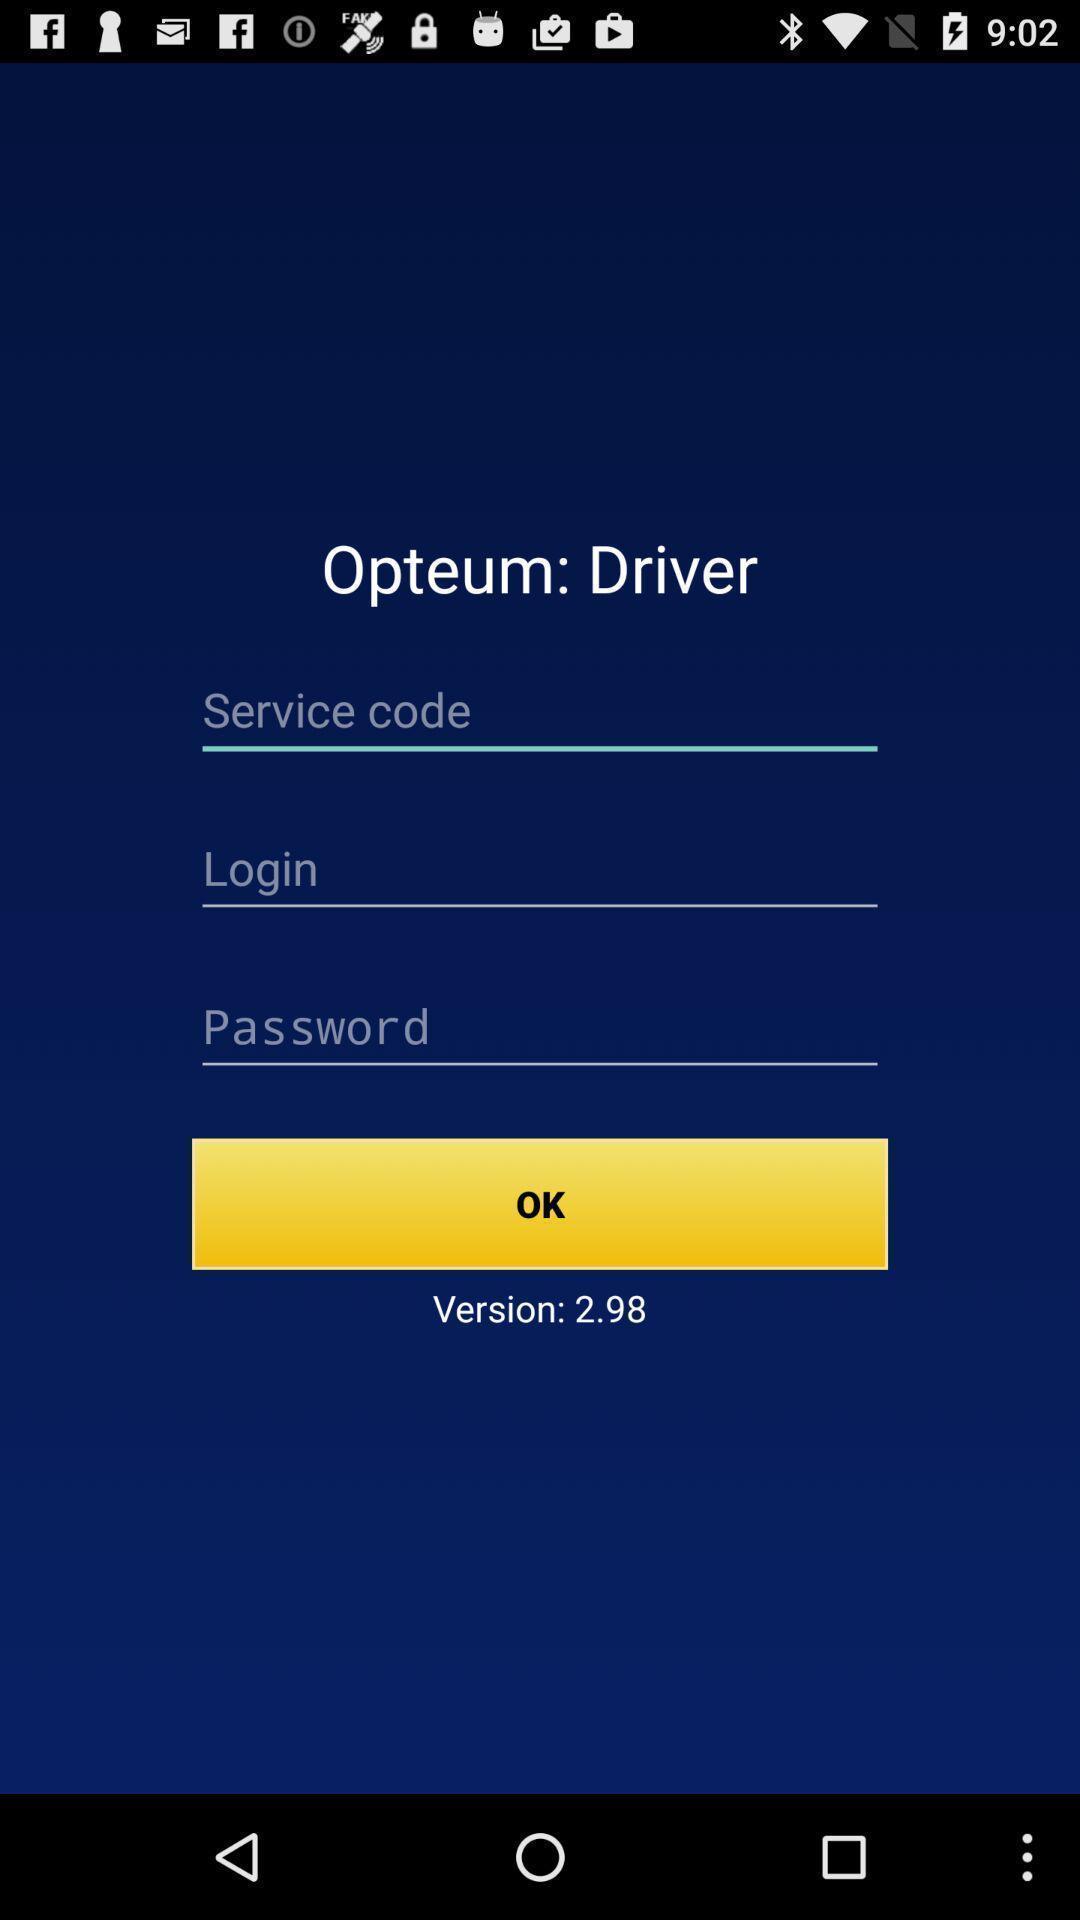Explain the elements present in this screenshot. Welcome page with login option. 